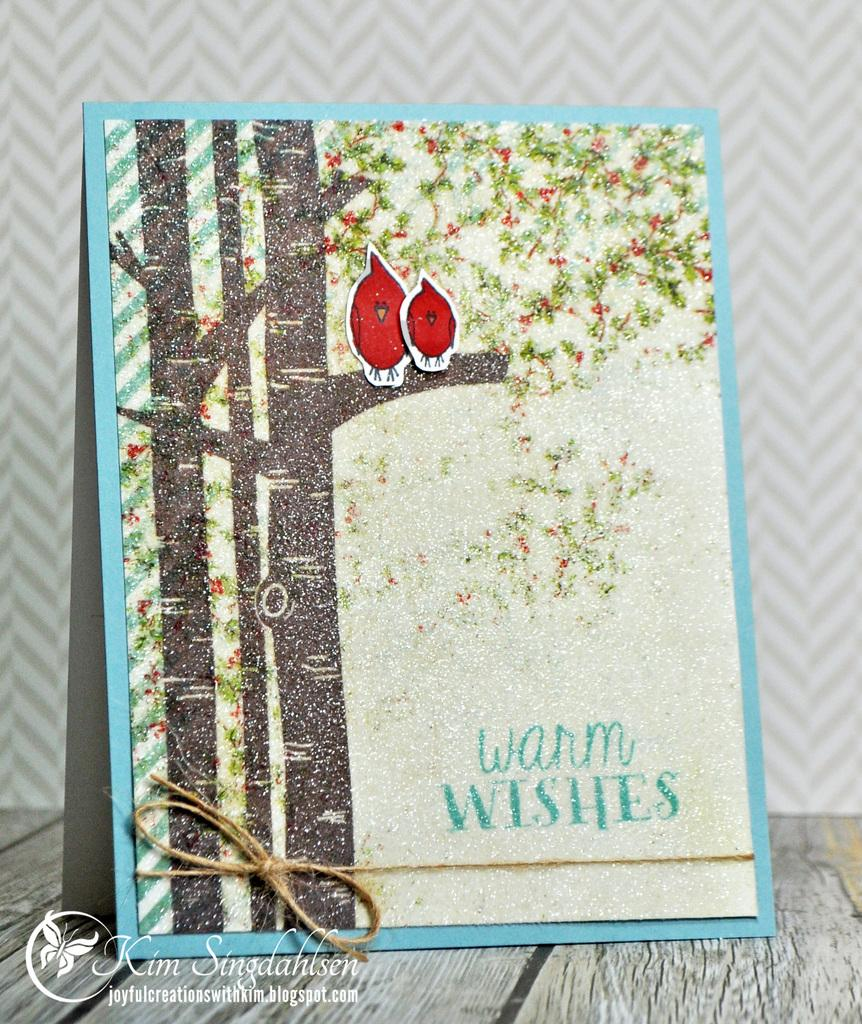What object is the main focus of the image? There is a greeting card in the image. Where is the greeting card located? The greeting card is on a platform. What is depicted on the greeting card? There are trees depicted on the greeting card. Can you describe any additional features of the greeting card? There is a watermark on the greeting card. What type of ear is visible on the greeting card? There is no ear depicted on the greeting card; it features trees instead. What sheet is used to create the watermark on the greeting card? The type of sheet used for the watermark is not mentioned in the image, as it only states that there is a watermark present. 